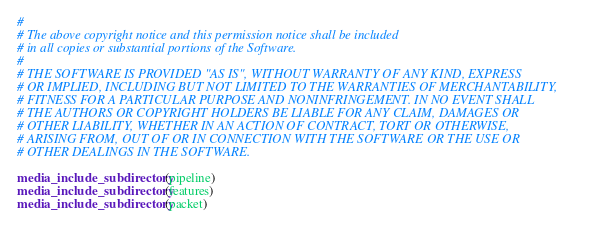Convert code to text. <code><loc_0><loc_0><loc_500><loc_500><_CMake_>#
# The above copyright notice and this permission notice shall be included
# in all copies or substantial portions of the Software.
#
# THE SOFTWARE IS PROVIDED "AS IS", WITHOUT WARRANTY OF ANY KIND, EXPRESS
# OR IMPLIED, INCLUDING BUT NOT LIMITED TO THE WARRANTIES OF MERCHANTABILITY,
# FITNESS FOR A PARTICULAR PURPOSE AND NONINFRINGEMENT. IN NO EVENT SHALL
# THE AUTHORS OR COPYRIGHT HOLDERS BE LIABLE FOR ANY CLAIM, DAMAGES OR
# OTHER LIABILITY, WHETHER IN AN ACTION OF CONTRACT, TORT OR OTHERWISE,
# ARISING FROM, OUT OF OR IN CONNECTION WITH THE SOFTWARE OR THE USE OR
# OTHER DEALINGS IN THE SOFTWARE.

media_include_subdirectory(pipeline)
media_include_subdirectory(features)
media_include_subdirectory(packet)
</code> 